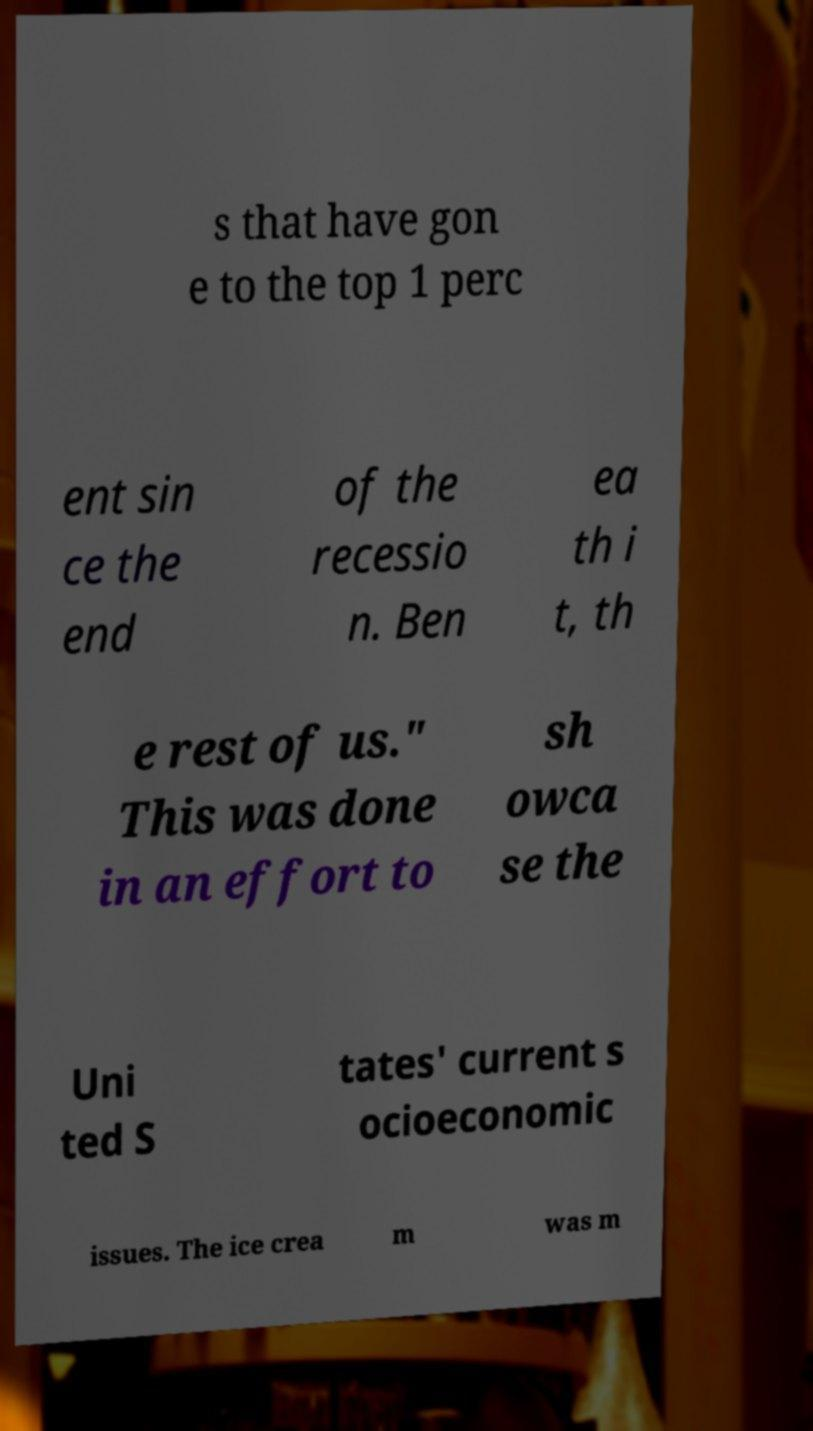What messages or text are displayed in this image? I need them in a readable, typed format. s that have gon e to the top 1 perc ent sin ce the end of the recessio n. Ben ea th i t, th e rest of us." This was done in an effort to sh owca se the Uni ted S tates' current s ocioeconomic issues. The ice crea m was m 